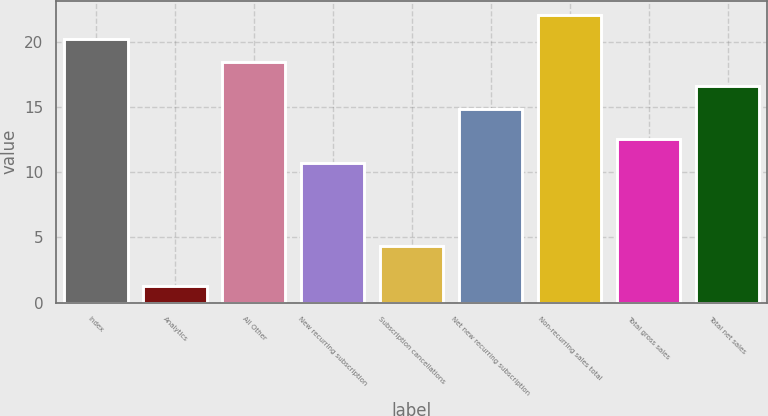<chart> <loc_0><loc_0><loc_500><loc_500><bar_chart><fcel>Index<fcel>Analytics<fcel>All Other<fcel>New recurring subscription<fcel>Subscription cancellations<fcel>Net new recurring subscription<fcel>Non-recurring sales total<fcel>Total gross sales<fcel>Total net sales<nl><fcel>20.2<fcel>1.3<fcel>18.4<fcel>10.7<fcel>4.3<fcel>14.8<fcel>22<fcel>12.5<fcel>16.6<nl></chart> 